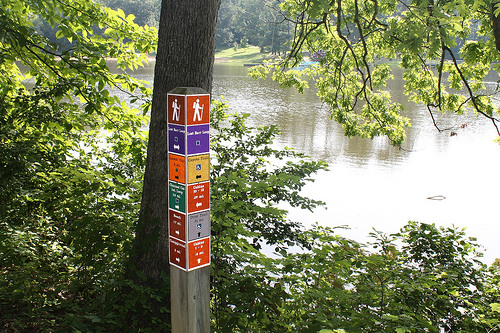<image>
Can you confirm if the river is to the right of the tree? Yes. From this viewpoint, the river is positioned to the right side relative to the tree. 